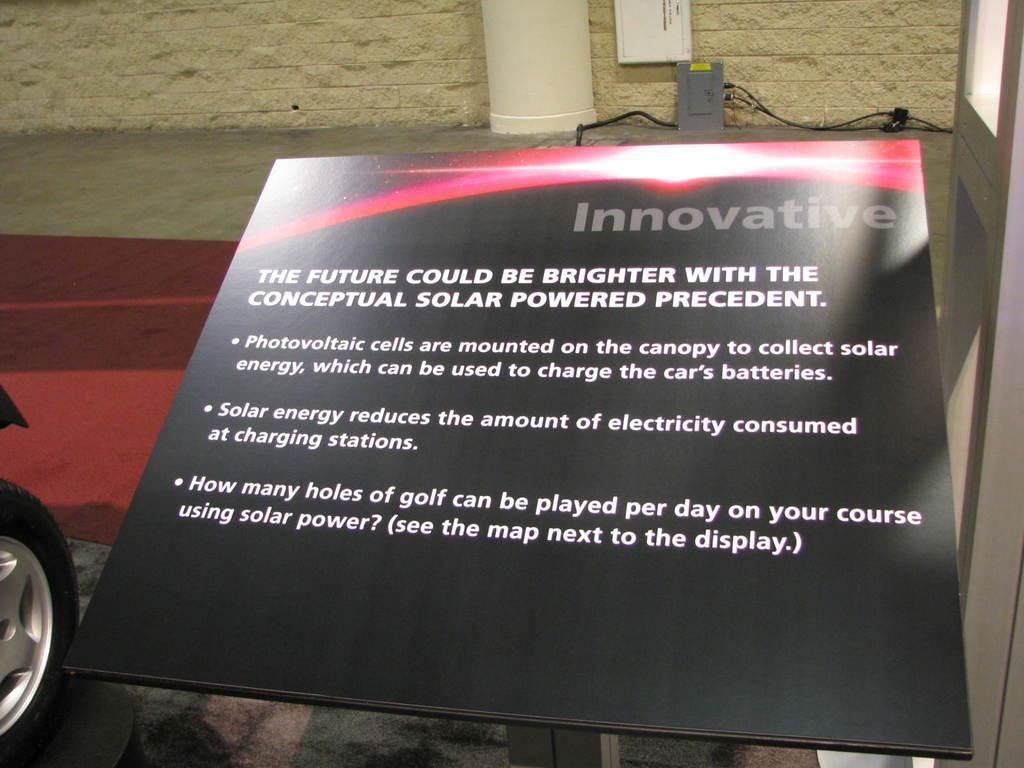Describe this image in one or two sentences. In the foreground of the image there is a board with some text on it. To the left side of the image there is a vehicle Tyre. In the background of the image there is wall. 